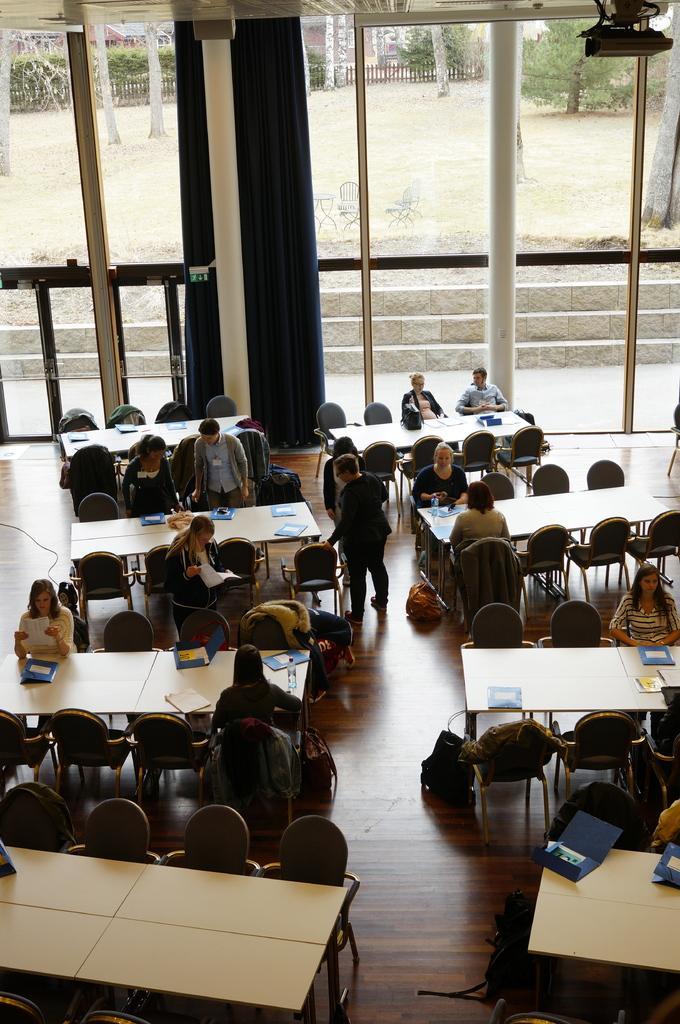Please provide a concise description of this image. In this image I can see few people are sitting on the chairs and few people are standing. There are some tables and chairs are arranged around the tables. In the background there is a glass window. Through that window we can see the outside view. On the tables we can see some books. 